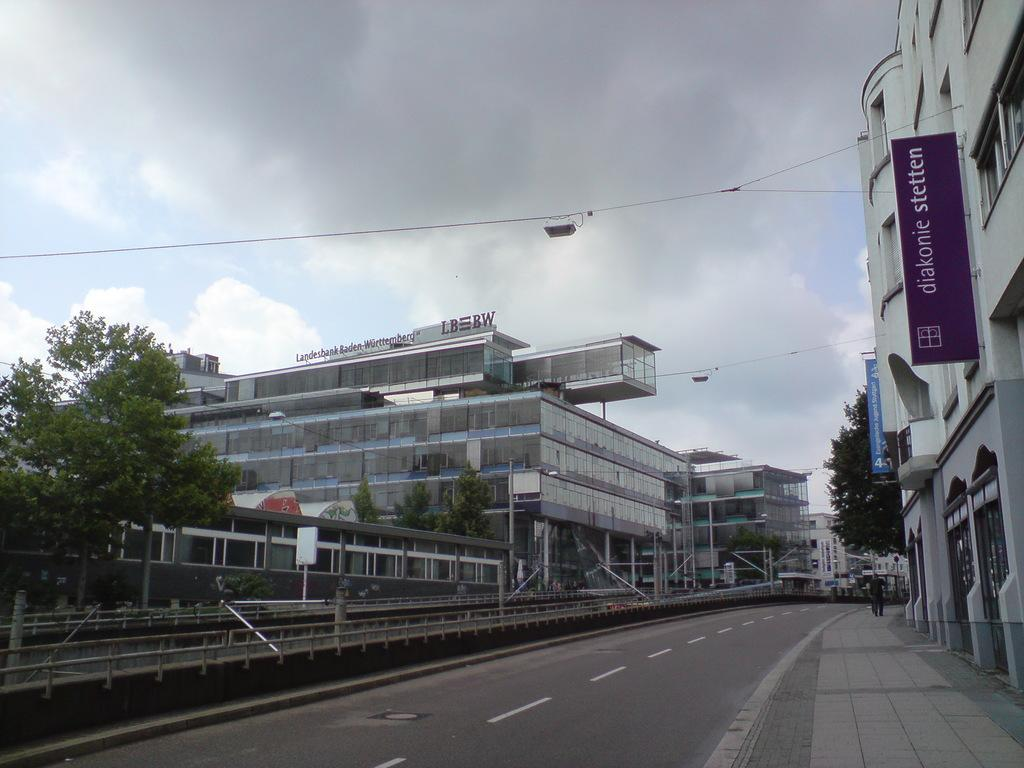What can be seen in the background of the image? There is sky in the image. What type of structures are present in the image? There are buildings in the image. What natural element is visible in the image? There is a tree in the image. What type of pathway is present in the image? There is a road in the image. What type of infrastructure is present in the image? There are wires in the image. What type of sign or notice is present in the image? There is a board in the image. What is the digestion process of the tree in the image? There is no digestion process for the tree in the image, as trees do not have a digestive system. What is the desire of the buildings in the image? Buildings do not have desires, as they are inanimate objects. 